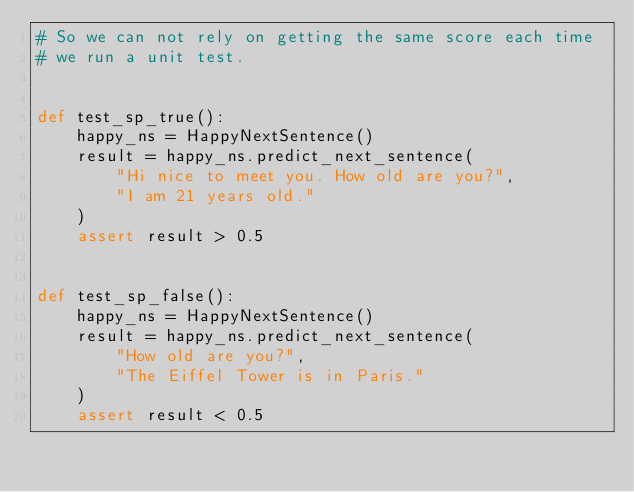Convert code to text. <code><loc_0><loc_0><loc_500><loc_500><_Python_># So we can not rely on getting the same score each time
# we run a unit test.


def test_sp_true():
    happy_ns = HappyNextSentence()
    result = happy_ns.predict_next_sentence(
        "Hi nice to meet you. How old are you?",
        "I am 21 years old."
    )
    assert result > 0.5


def test_sp_false():
    happy_ns = HappyNextSentence()
    result = happy_ns.predict_next_sentence(
        "How old are you?",
        "The Eiffel Tower is in Paris."
    )
    assert result < 0.5


</code> 